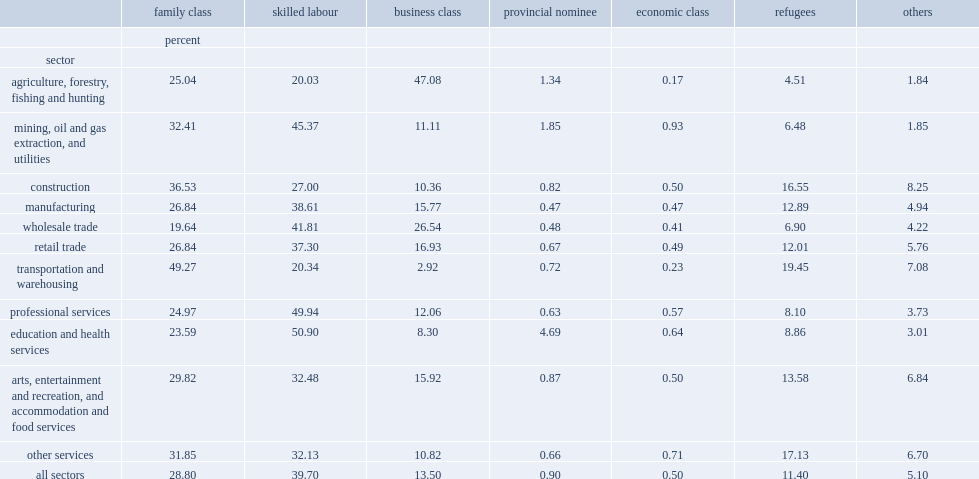Which class did immigrants admit in make up the largest group across all sectors? Skilled labour. Which class ranked second across all sectors? Family class. Which class intended to attract investment ranked third across all sectors? Business class. Which class ranks fourth and account for 11% of immigrant business owners? Refugees. 